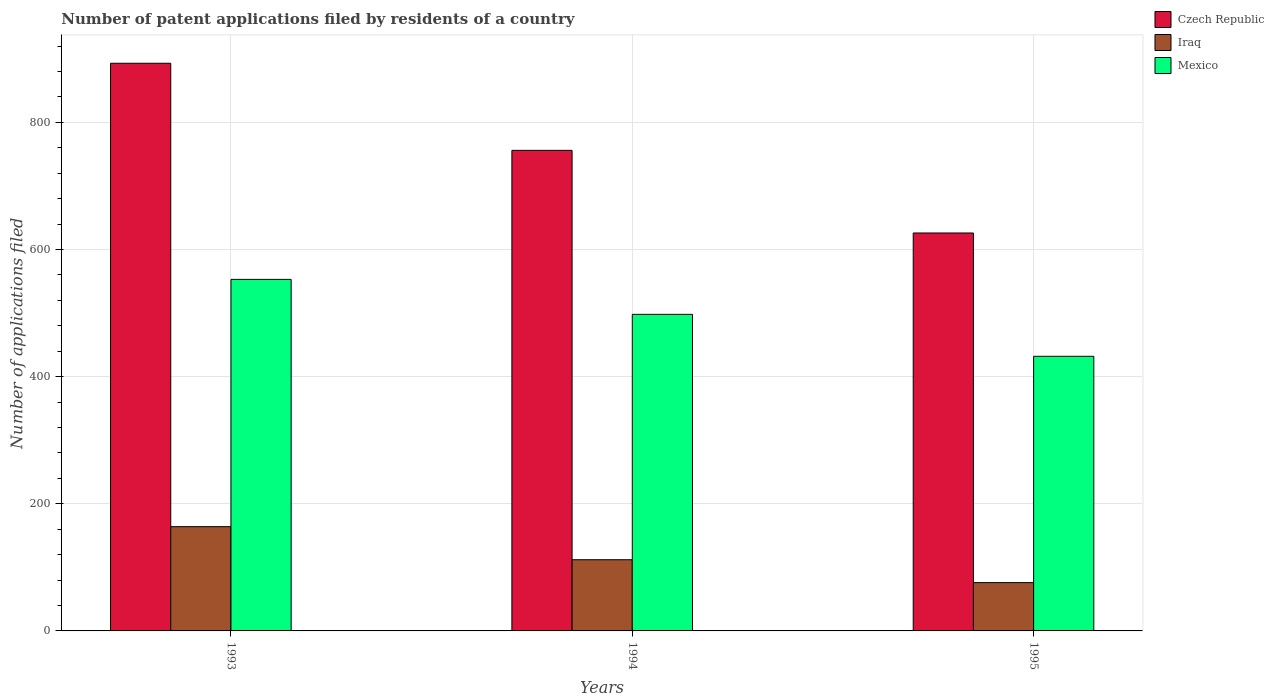How many different coloured bars are there?
Give a very brief answer. 3. How many groups of bars are there?
Offer a very short reply. 3. How many bars are there on the 1st tick from the left?
Provide a short and direct response. 3. What is the label of the 2nd group of bars from the left?
Keep it short and to the point. 1994. In how many cases, is the number of bars for a given year not equal to the number of legend labels?
Keep it short and to the point. 0. What is the number of applications filed in Iraq in 1994?
Provide a succinct answer. 112. Across all years, what is the maximum number of applications filed in Czech Republic?
Ensure brevity in your answer.  893. Across all years, what is the minimum number of applications filed in Mexico?
Provide a short and direct response. 432. In which year was the number of applications filed in Mexico maximum?
Offer a terse response. 1993. In which year was the number of applications filed in Mexico minimum?
Your response must be concise. 1995. What is the total number of applications filed in Iraq in the graph?
Your answer should be compact. 352. What is the difference between the number of applications filed in Mexico in 1994 and the number of applications filed in Iraq in 1995?
Your answer should be compact. 422. What is the average number of applications filed in Mexico per year?
Your answer should be compact. 494.33. In the year 1994, what is the difference between the number of applications filed in Mexico and number of applications filed in Iraq?
Make the answer very short. 386. In how many years, is the number of applications filed in Mexico greater than 280?
Provide a succinct answer. 3. What is the ratio of the number of applications filed in Czech Republic in 1994 to that in 1995?
Your answer should be very brief. 1.21. Is the number of applications filed in Iraq in 1993 less than that in 1994?
Your response must be concise. No. Is the difference between the number of applications filed in Mexico in 1993 and 1994 greater than the difference between the number of applications filed in Iraq in 1993 and 1994?
Your response must be concise. Yes. In how many years, is the number of applications filed in Iraq greater than the average number of applications filed in Iraq taken over all years?
Your answer should be very brief. 1. Is the sum of the number of applications filed in Mexico in 1994 and 1995 greater than the maximum number of applications filed in Iraq across all years?
Your answer should be very brief. Yes. What does the 1st bar from the left in 1993 represents?
Ensure brevity in your answer.  Czech Republic. What does the 1st bar from the right in 1994 represents?
Offer a very short reply. Mexico. Is it the case that in every year, the sum of the number of applications filed in Mexico and number of applications filed in Iraq is greater than the number of applications filed in Czech Republic?
Your answer should be compact. No. Are all the bars in the graph horizontal?
Provide a short and direct response. No. How many legend labels are there?
Ensure brevity in your answer.  3. What is the title of the graph?
Provide a short and direct response. Number of patent applications filed by residents of a country. Does "St. Kitts and Nevis" appear as one of the legend labels in the graph?
Offer a very short reply. No. What is the label or title of the X-axis?
Make the answer very short. Years. What is the label or title of the Y-axis?
Offer a very short reply. Number of applications filed. What is the Number of applications filed of Czech Republic in 1993?
Provide a short and direct response. 893. What is the Number of applications filed of Iraq in 1993?
Your response must be concise. 164. What is the Number of applications filed of Mexico in 1993?
Offer a terse response. 553. What is the Number of applications filed in Czech Republic in 1994?
Offer a very short reply. 756. What is the Number of applications filed in Iraq in 1994?
Offer a very short reply. 112. What is the Number of applications filed of Mexico in 1994?
Make the answer very short. 498. What is the Number of applications filed in Czech Republic in 1995?
Give a very brief answer. 626. What is the Number of applications filed of Iraq in 1995?
Your answer should be compact. 76. What is the Number of applications filed of Mexico in 1995?
Make the answer very short. 432. Across all years, what is the maximum Number of applications filed of Czech Republic?
Provide a short and direct response. 893. Across all years, what is the maximum Number of applications filed in Iraq?
Offer a very short reply. 164. Across all years, what is the maximum Number of applications filed in Mexico?
Keep it short and to the point. 553. Across all years, what is the minimum Number of applications filed in Czech Republic?
Your answer should be very brief. 626. Across all years, what is the minimum Number of applications filed in Iraq?
Provide a short and direct response. 76. Across all years, what is the minimum Number of applications filed in Mexico?
Provide a succinct answer. 432. What is the total Number of applications filed of Czech Republic in the graph?
Give a very brief answer. 2275. What is the total Number of applications filed of Iraq in the graph?
Give a very brief answer. 352. What is the total Number of applications filed of Mexico in the graph?
Provide a succinct answer. 1483. What is the difference between the Number of applications filed of Czech Republic in 1993 and that in 1994?
Offer a very short reply. 137. What is the difference between the Number of applications filed in Iraq in 1993 and that in 1994?
Give a very brief answer. 52. What is the difference between the Number of applications filed of Czech Republic in 1993 and that in 1995?
Your answer should be compact. 267. What is the difference between the Number of applications filed in Iraq in 1993 and that in 1995?
Provide a short and direct response. 88. What is the difference between the Number of applications filed in Mexico in 1993 and that in 1995?
Your response must be concise. 121. What is the difference between the Number of applications filed in Czech Republic in 1994 and that in 1995?
Give a very brief answer. 130. What is the difference between the Number of applications filed in Iraq in 1994 and that in 1995?
Give a very brief answer. 36. What is the difference between the Number of applications filed in Czech Republic in 1993 and the Number of applications filed in Iraq in 1994?
Offer a terse response. 781. What is the difference between the Number of applications filed of Czech Republic in 1993 and the Number of applications filed of Mexico in 1994?
Your answer should be compact. 395. What is the difference between the Number of applications filed in Iraq in 1993 and the Number of applications filed in Mexico in 1994?
Provide a succinct answer. -334. What is the difference between the Number of applications filed in Czech Republic in 1993 and the Number of applications filed in Iraq in 1995?
Your response must be concise. 817. What is the difference between the Number of applications filed in Czech Republic in 1993 and the Number of applications filed in Mexico in 1995?
Your answer should be very brief. 461. What is the difference between the Number of applications filed in Iraq in 1993 and the Number of applications filed in Mexico in 1995?
Your answer should be compact. -268. What is the difference between the Number of applications filed of Czech Republic in 1994 and the Number of applications filed of Iraq in 1995?
Give a very brief answer. 680. What is the difference between the Number of applications filed in Czech Republic in 1994 and the Number of applications filed in Mexico in 1995?
Offer a terse response. 324. What is the difference between the Number of applications filed in Iraq in 1994 and the Number of applications filed in Mexico in 1995?
Your answer should be very brief. -320. What is the average Number of applications filed of Czech Republic per year?
Your answer should be very brief. 758.33. What is the average Number of applications filed in Iraq per year?
Ensure brevity in your answer.  117.33. What is the average Number of applications filed of Mexico per year?
Your answer should be very brief. 494.33. In the year 1993, what is the difference between the Number of applications filed in Czech Republic and Number of applications filed in Iraq?
Your response must be concise. 729. In the year 1993, what is the difference between the Number of applications filed of Czech Republic and Number of applications filed of Mexico?
Your response must be concise. 340. In the year 1993, what is the difference between the Number of applications filed of Iraq and Number of applications filed of Mexico?
Provide a short and direct response. -389. In the year 1994, what is the difference between the Number of applications filed in Czech Republic and Number of applications filed in Iraq?
Give a very brief answer. 644. In the year 1994, what is the difference between the Number of applications filed of Czech Republic and Number of applications filed of Mexico?
Keep it short and to the point. 258. In the year 1994, what is the difference between the Number of applications filed of Iraq and Number of applications filed of Mexico?
Your response must be concise. -386. In the year 1995, what is the difference between the Number of applications filed of Czech Republic and Number of applications filed of Iraq?
Provide a short and direct response. 550. In the year 1995, what is the difference between the Number of applications filed in Czech Republic and Number of applications filed in Mexico?
Your answer should be compact. 194. In the year 1995, what is the difference between the Number of applications filed in Iraq and Number of applications filed in Mexico?
Provide a succinct answer. -356. What is the ratio of the Number of applications filed in Czech Republic in 1993 to that in 1994?
Ensure brevity in your answer.  1.18. What is the ratio of the Number of applications filed of Iraq in 1993 to that in 1994?
Your answer should be compact. 1.46. What is the ratio of the Number of applications filed in Mexico in 1993 to that in 1994?
Offer a very short reply. 1.11. What is the ratio of the Number of applications filed in Czech Republic in 1993 to that in 1995?
Provide a succinct answer. 1.43. What is the ratio of the Number of applications filed in Iraq in 1993 to that in 1995?
Offer a terse response. 2.16. What is the ratio of the Number of applications filed of Mexico in 1993 to that in 1995?
Ensure brevity in your answer.  1.28. What is the ratio of the Number of applications filed of Czech Republic in 1994 to that in 1995?
Offer a very short reply. 1.21. What is the ratio of the Number of applications filed of Iraq in 1994 to that in 1995?
Offer a terse response. 1.47. What is the ratio of the Number of applications filed of Mexico in 1994 to that in 1995?
Provide a succinct answer. 1.15. What is the difference between the highest and the second highest Number of applications filed of Czech Republic?
Offer a terse response. 137. What is the difference between the highest and the second highest Number of applications filed in Iraq?
Offer a very short reply. 52. What is the difference between the highest and the second highest Number of applications filed of Mexico?
Keep it short and to the point. 55. What is the difference between the highest and the lowest Number of applications filed in Czech Republic?
Offer a very short reply. 267. What is the difference between the highest and the lowest Number of applications filed in Mexico?
Your response must be concise. 121. 